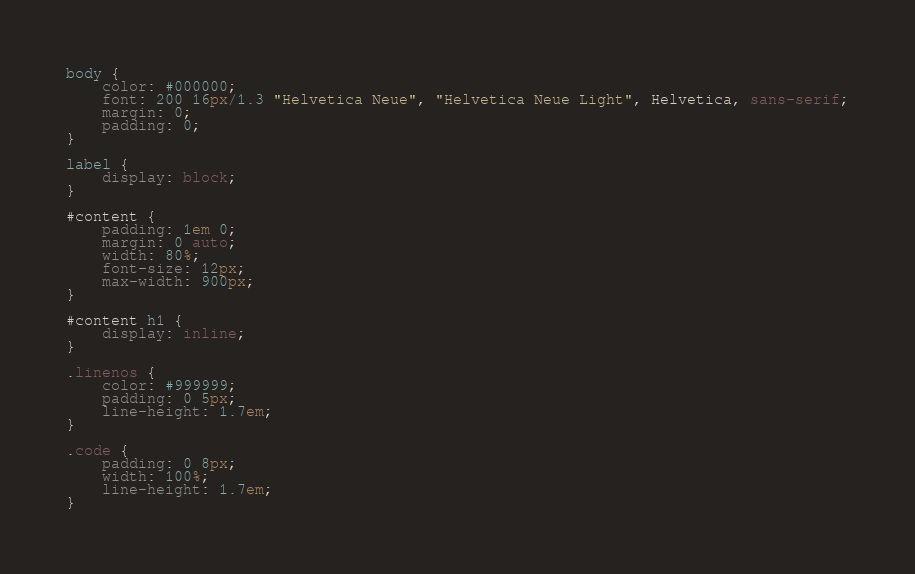<code> <loc_0><loc_0><loc_500><loc_500><_CSS_>body {
    color: #000000;
    font: 200 16px/1.3 "Helvetica Neue", "Helvetica Neue Light", Helvetica, sans-serif;
    margin: 0;
    padding: 0;
}

label { 
    display: block; 
}

#content {
    padding: 1em 0;
    margin: 0 auto;
    width: 80%;
    font-size: 12px;
    max-width: 900px;
}

#content h1 {
    display: inline;
}

.linenos {
    color: #999999;
    padding: 0 5px;
    line-height: 1.7em;
}

.code {
    padding: 0 8px;
    width: 100%;
    line-height: 1.7em;
}
</code> 